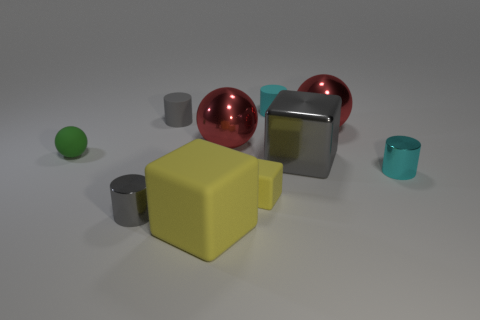Subtract all cubes. How many objects are left? 7 Add 6 small yellow metal cylinders. How many small yellow metal cylinders exist? 6 Subtract 0 red cubes. How many objects are left? 10 Subtract all tiny blue blocks. Subtract all tiny cyan metallic cylinders. How many objects are left? 9 Add 8 green objects. How many green objects are left? 9 